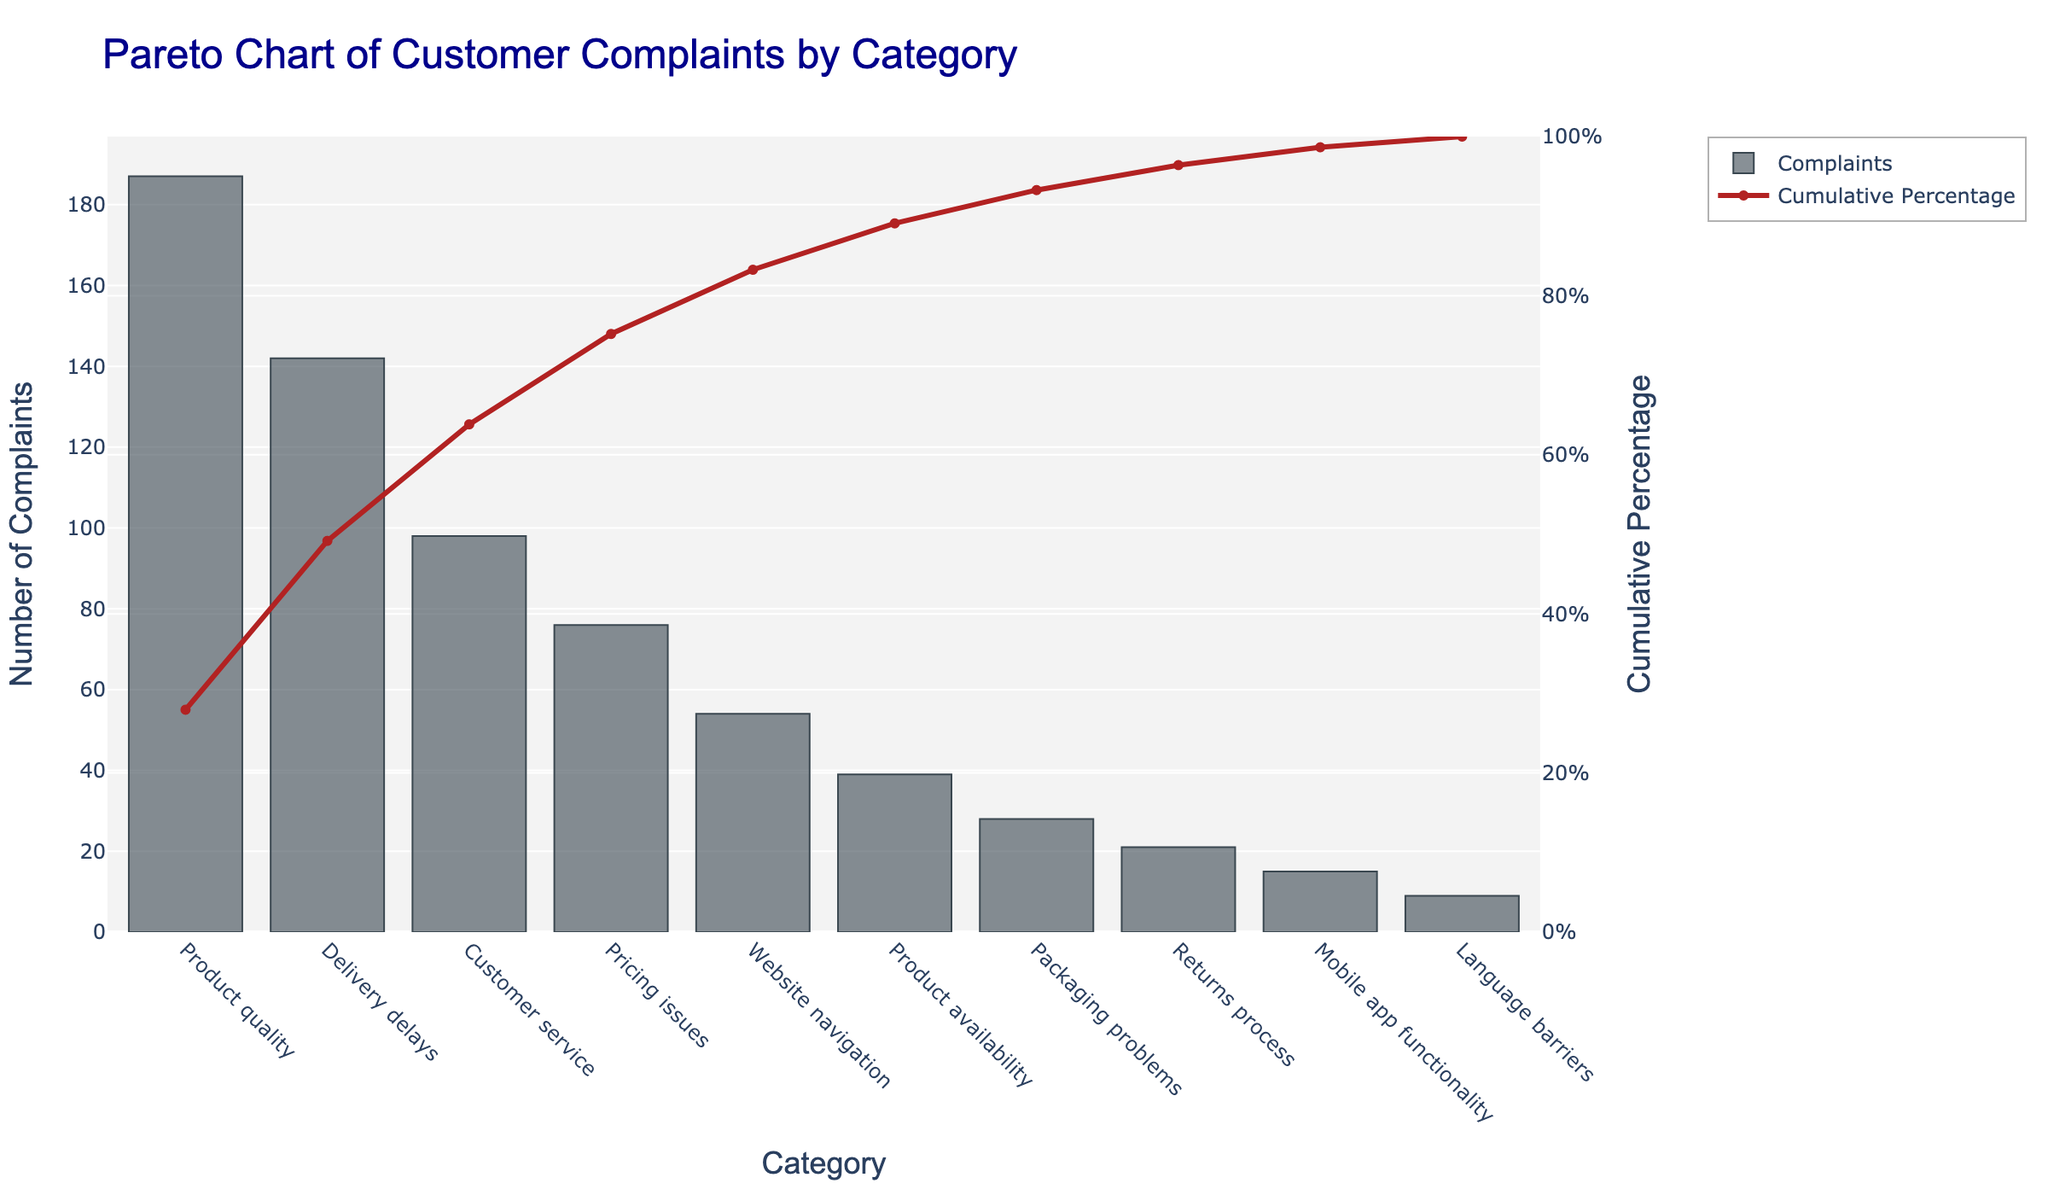What is the title of the chart? The title of the chart is displayed prominently at the top. It reads "Pareto Chart of Customer Complaints by Category".
Answer: Pareto Chart of Customer Complaints by Category What category has the highest number of customer complaints? By looking at the bar heights, the "Product quality" category has the tallest bar, indicating the highest number of complaints.
Answer: Product quality What is the cumulative percentage of customer complaints covered by "Product quality" and "Delivery delays"? "Product quality" has a cumulative percentage of 23.7% and "Delivery delays" plus that equals approximately 41.7%. Add these percentages directly from the chart.
Answer: 41.7% How many complaints were recorded for "Customer service"? The "Customer service" bar's height aligns with the number 98 on the y-axis for complaints.
Answer: 98 Which category has the lowest number of complaints, and how many complaints were there? The "Language barriers" category has the shortest bar with a height indicating that there are 9 complaints.
Answer: Language barriers, 9 Which category's cumulative percentage is closest to 80%? Observing the line graph, the "Returns process" category is closest to the 80% mark.
Answer: Returns process Explain the significance of the line in the Pareto chart. The line represents the cumulative percentage of complaints. As you move from left to right, it shows the progressive total of complaints, highlighting how quickly the complaints add up across categories.
Answer: It shows cumulative percentage What is the combined number of complaints for "Packaging problems" and "Returns process"? "Packaging problems" has 28 complaints and "Returns process" has 21. Adding these together results in 49 complaints.
Answer: 49 Which two categories combined cover just over 50% of the total complaints? The bar values and cumulative percentage line indicates that "Product quality" (23.7%) and "Delivery delays" (17.9%) together cover 41.6%. Adding "Customer service" (12.4%) cumulatively covers over 50%
Answer: Product quality and Delivery delays What percentage of total complaints is accounted for by the "Mobile app functionality" category? The "Mobile app functionality" bar's cumulative percentage is at approximately 92.5% and knowing the previous category's cumulative percentage is 91.5%, the difference suggests it accounts for 1% of complaints.
Answer: 1% 